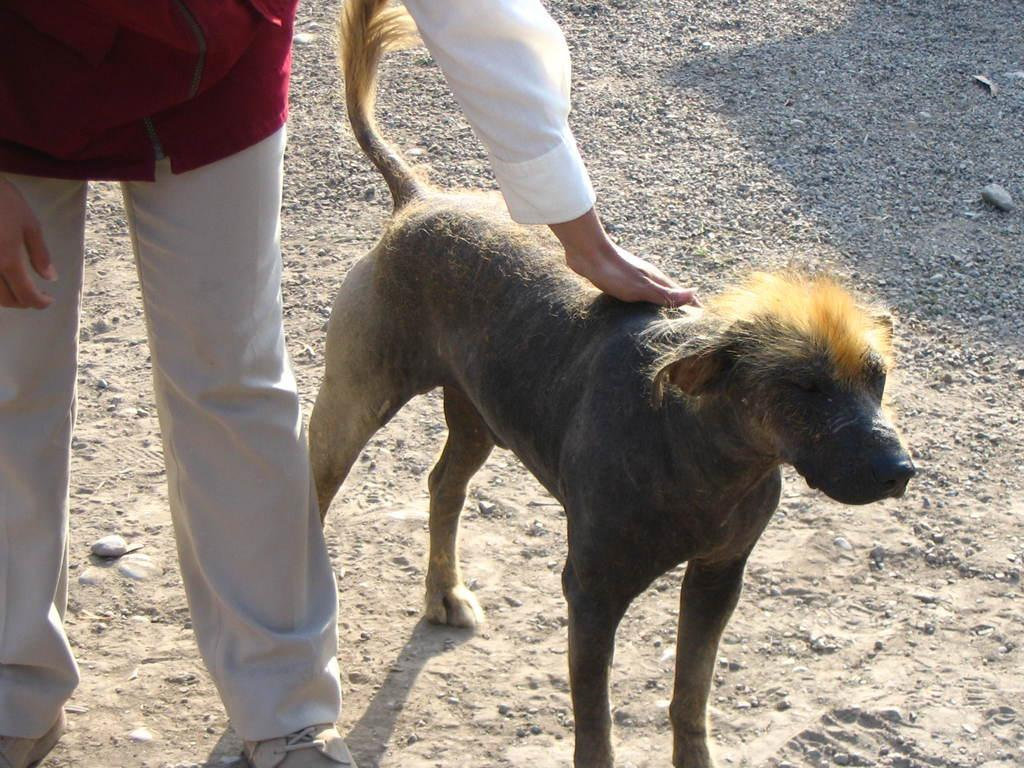What type of animal is present in the image? There is a dog in the image. Can you describe the person on the left side of the image? The person is wearing a red jacket. What is at the bottom of the image? There is a road at the bottom of the image. What type of stick can be seen in the night sky in the image? There is no stick or night sky present in the image; it features a dog and a person wearing a red jacket with a road at the bottom. 